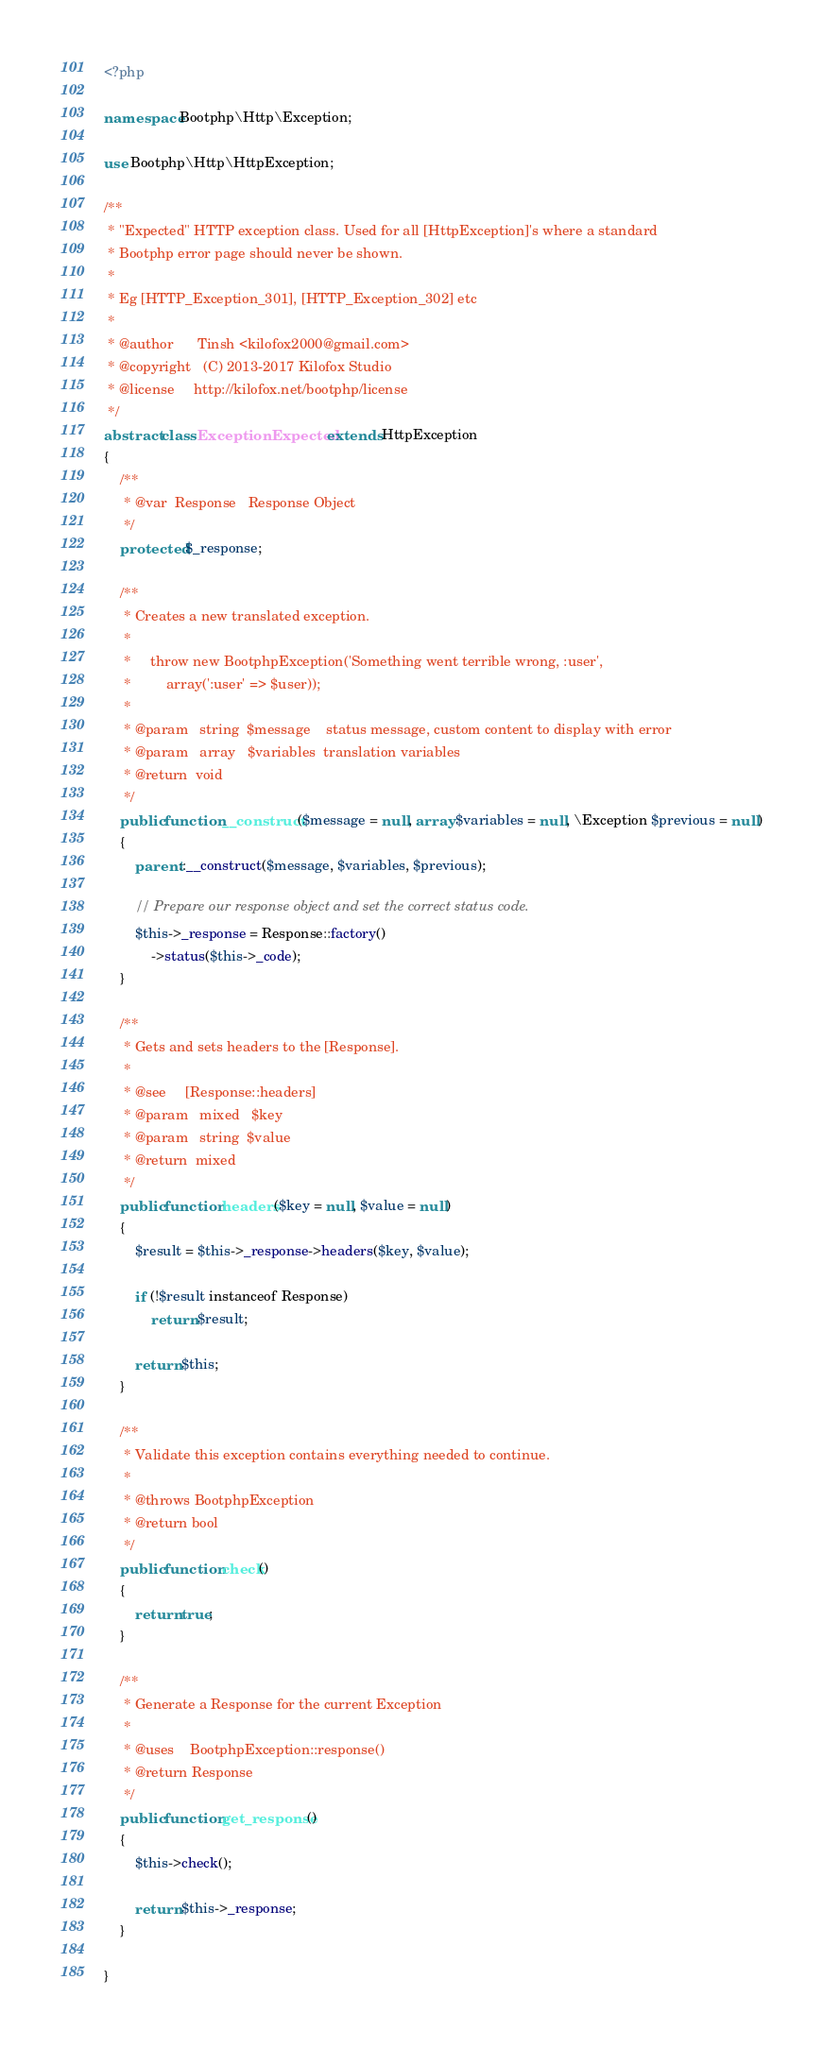Convert code to text. <code><loc_0><loc_0><loc_500><loc_500><_PHP_><?php

namespace Bootphp\Http\Exception;

use Bootphp\Http\HttpException;

/**
 * "Expected" HTTP exception class. Used for all [HttpException]'s where a standard
 * Bootphp error page should never be shown.
 *
 * Eg [HTTP_Exception_301], [HTTP_Exception_302] etc
 *
 * @author      Tinsh <kilofox2000@gmail.com>
 * @copyright   (C) 2013-2017 Kilofox Studio
 * @license     http://kilofox.net/bootphp/license
 */
abstract class ExceptionExpected extends HttpException
{
    /**
     * @var  Response   Response Object
     */
    protected $_response;

    /**
     * Creates a new translated exception.
     *
     *     throw new BootphpException('Something went terrible wrong, :user',
     *         array(':user' => $user));
     *
     * @param   string  $message    status message, custom content to display with error
     * @param   array   $variables  translation variables
     * @return  void
     */
    public function __construct($message = null, array $variables = null, \Exception $previous = null)
    {
        parent::__construct($message, $variables, $previous);

        // Prepare our response object and set the correct status code.
        $this->_response = Response::factory()
            ->status($this->_code);
    }

    /**
     * Gets and sets headers to the [Response].
     *
     * @see     [Response::headers]
     * @param   mixed   $key
     * @param   string  $value
     * @return  mixed
     */
    public function headers($key = null, $value = null)
    {
        $result = $this->_response->headers($key, $value);

        if (!$result instanceof Response)
            return $result;

        return $this;
    }

    /**
     * Validate this exception contains everything needed to continue.
     *
     * @throws BootphpException
     * @return bool
     */
    public function check()
    {
        return true;
    }

    /**
     * Generate a Response for the current Exception
     *
     * @uses    BootphpException::response()
     * @return Response
     */
    public function get_response()
    {
        $this->check();

        return $this->_response;
    }

}
</code> 